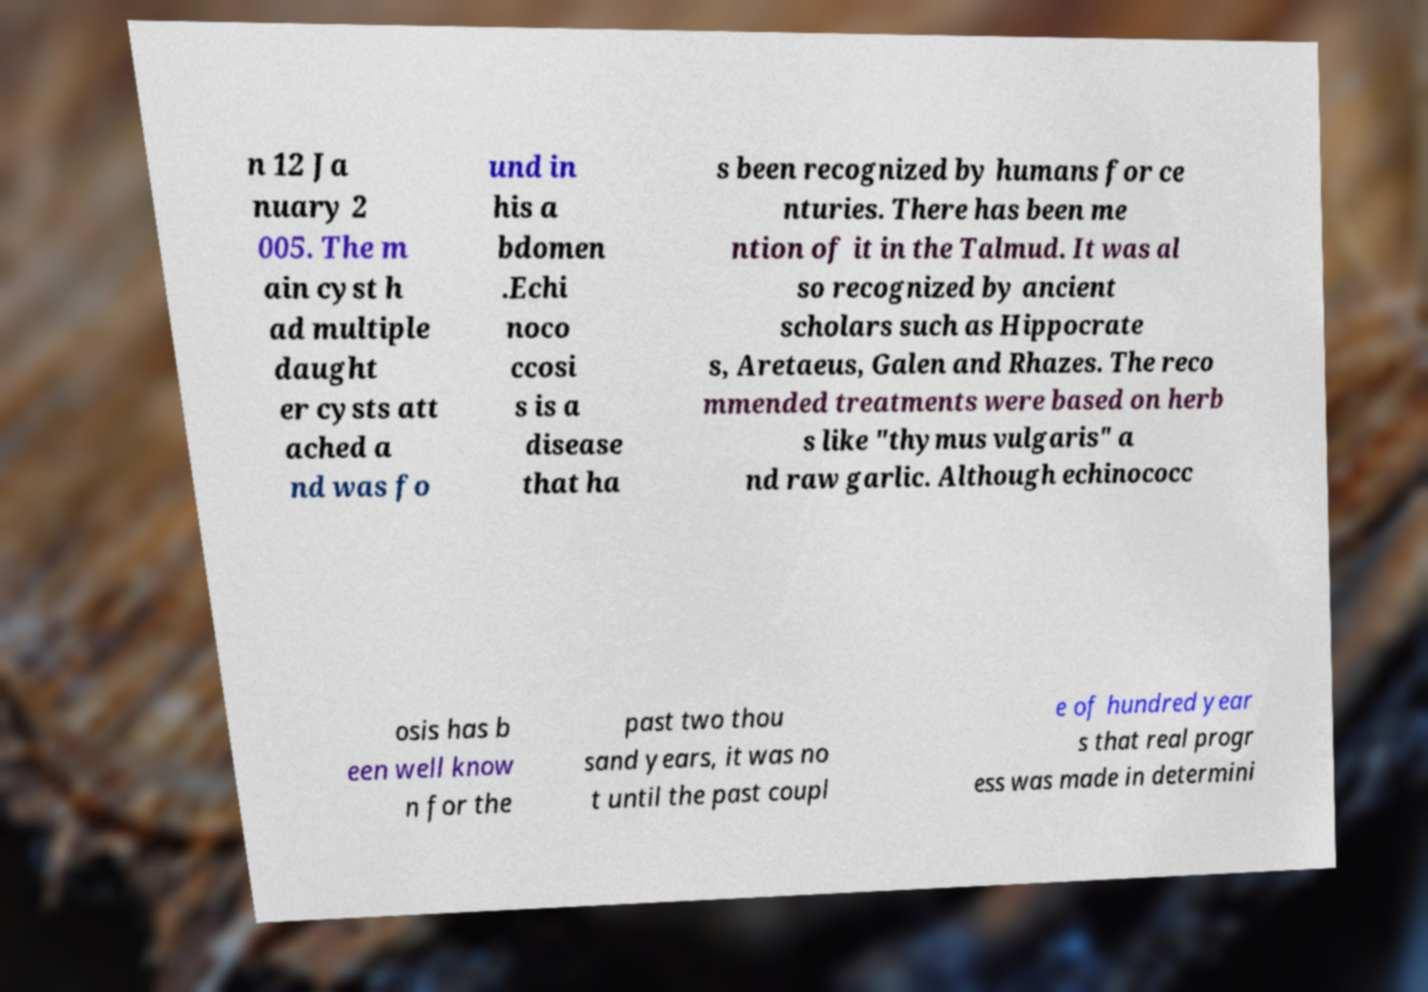Can you read and provide the text displayed in the image?This photo seems to have some interesting text. Can you extract and type it out for me? n 12 Ja nuary 2 005. The m ain cyst h ad multiple daught er cysts att ached a nd was fo und in his a bdomen .Echi noco ccosi s is a disease that ha s been recognized by humans for ce nturies. There has been me ntion of it in the Talmud. It was al so recognized by ancient scholars such as Hippocrate s, Aretaeus, Galen and Rhazes. The reco mmended treatments were based on herb s like "thymus vulgaris" a nd raw garlic. Although echinococc osis has b een well know n for the past two thou sand years, it was no t until the past coupl e of hundred year s that real progr ess was made in determini 